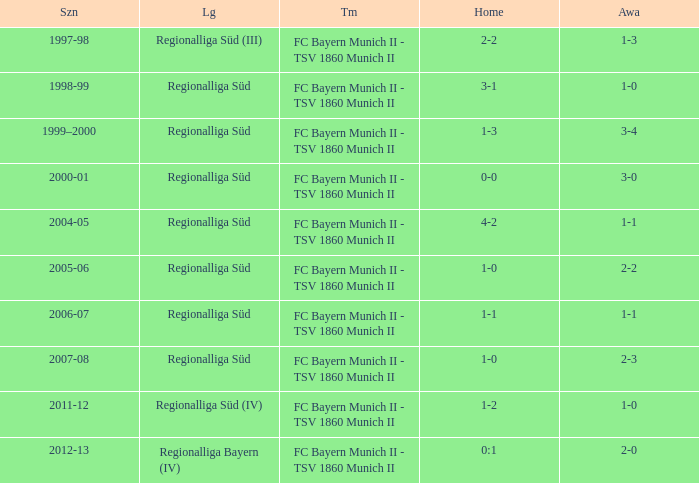What season has a regionalliga süd league, a 1-0 home, and an away of 2-3? 2007-08. 